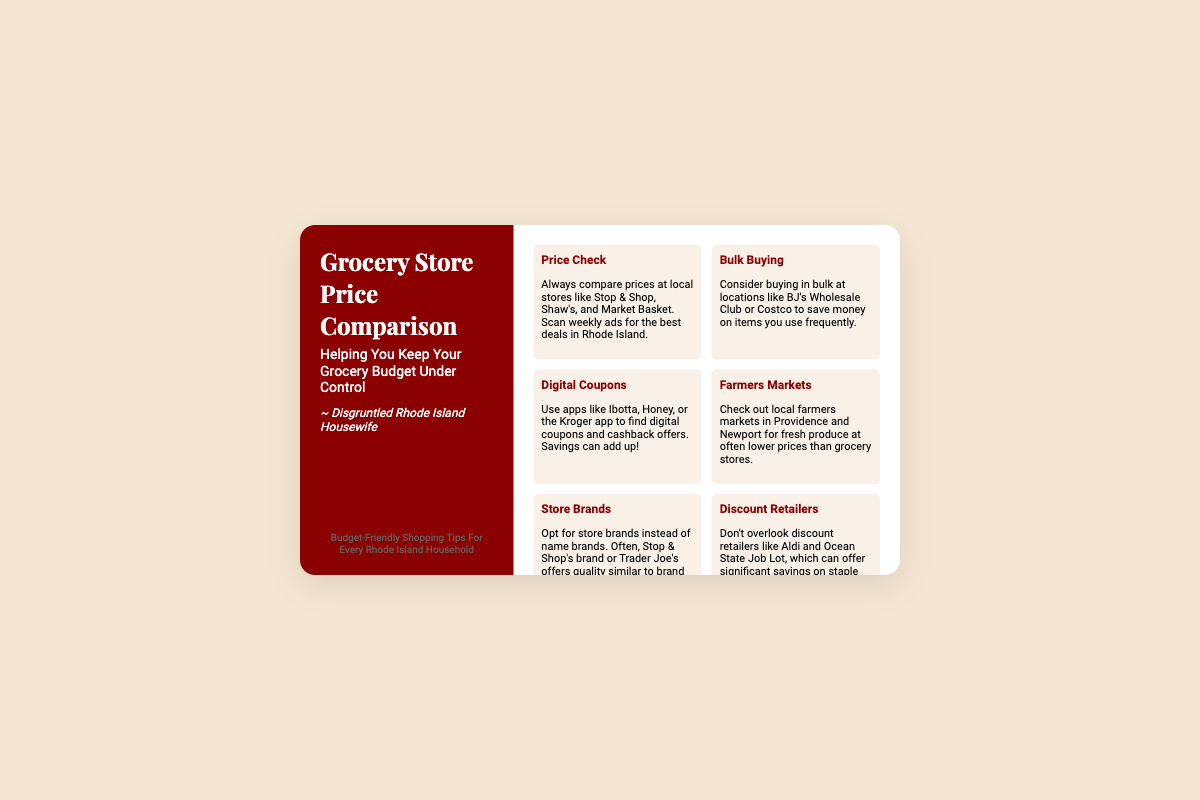what is the title of the document? The title given in the document is "Grocery Store Price Comparison."
Answer: Grocery Store Price Comparison who is the intended audience on the business card? The persona section specifies it is aimed at a "Disgruntled Rhode Island Housewife."
Answer: Disgruntled Rhode Island Housewife how many grocery budget tips are listed in the document? There are six tips mentioned in the tips section of the business card.
Answer: 6 what type of stores should one compare prices at according to the tips? The document suggests comparing prices at "local stores like Stop & Shop, Shaw's, and Market Basket."
Answer: Stop & Shop, Shaw's, and Market Basket which app is recommended for finding digital coupons? The document mentions "Ibotta" as an app to use for digital coupons.
Answer: Ibotta what is advised for purchasing frequently used items? The tip suggests "bulk buying" at wholesale locations.
Answer: bulk buying what is a recommended place to buy fresh produce? The document advises checking out "local farmers markets in Providence and Newport."
Answer: local farmers markets in Providence and Newport which discount retailer is mentioned in the tips? The document lists "Aldi" as a discount retailer that can offer savings.
Answer: Aldi 